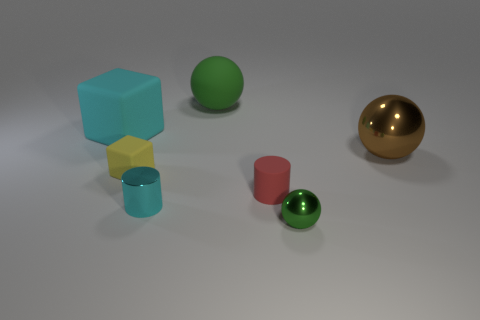The tiny rubber thing that is the same shape as the large cyan matte thing is what color?
Give a very brief answer. Yellow. Is the number of green metal objects that are on the right side of the small cyan object greater than the number of small cyan metallic cylinders behind the yellow object?
Ensure brevity in your answer.  Yes. What number of other things are the same shape as the brown metal object?
Your answer should be very brief. 2. There is a rubber object that is behind the large cyan rubber object; are there any big objects on the right side of it?
Provide a succinct answer. Yes. What number of small cubes are there?
Your answer should be very brief. 1. There is a matte ball; is it the same color as the ball that is in front of the shiny cylinder?
Offer a very short reply. Yes. Is the number of brown things greater than the number of cyan objects?
Ensure brevity in your answer.  No. Is there any other thing that has the same color as the matte cylinder?
Offer a very short reply. No. How many other objects are there of the same size as the brown thing?
Offer a very short reply. 2. There is a green object that is in front of the metallic sphere behind the small object to the left of the cyan metal cylinder; what is its material?
Your answer should be compact. Metal. 